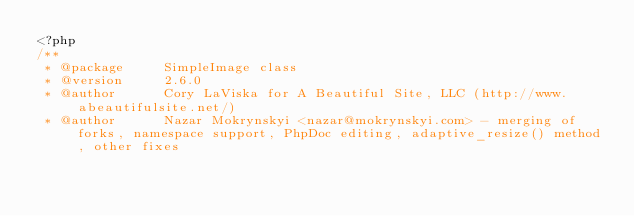<code> <loc_0><loc_0><loc_500><loc_500><_PHP_><?php
/**
 * @package     SimpleImage class
 * @version     2.6.0
 * @author      Cory LaViska for A Beautiful Site, LLC (http://www.abeautifulsite.net/)
 * @author      Nazar Mokrynskyi <nazar@mokrynskyi.com> - merging of forks, namespace support, PhpDoc editing, adaptive_resize() method, other fixes</code> 